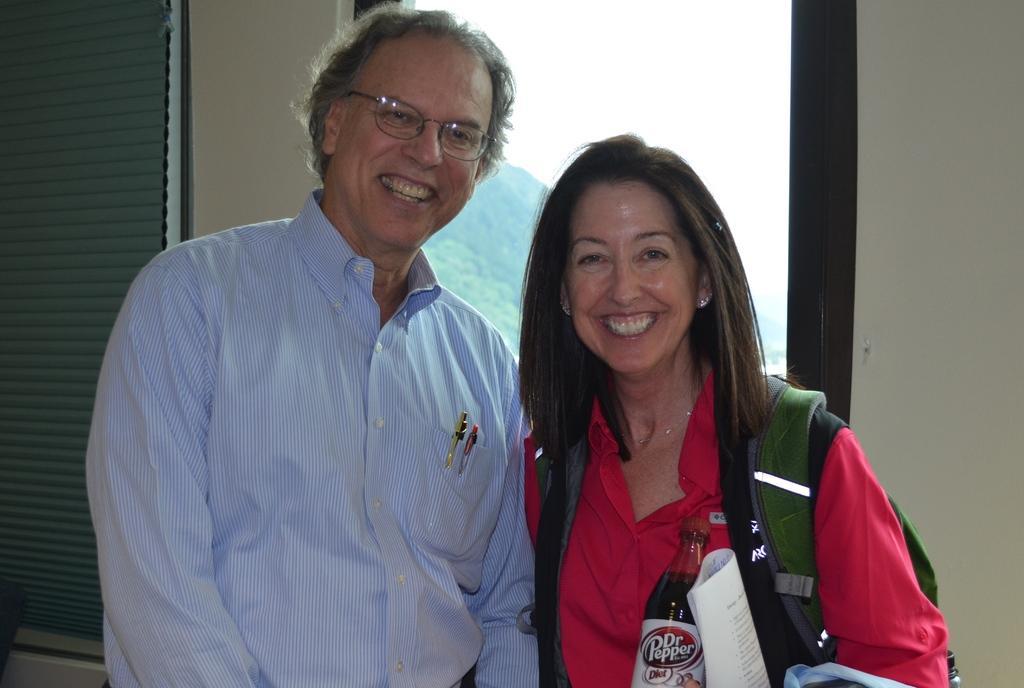Please provide a concise description of this image. In this image I can see two people are standing and smiling. Among them one person is wearing the blue shirt and another one is wearing the red shirt. Woman is holding a paper and bottle. And she is wearing the bag. To the left there is a window blind and In the back there are trees and the sky. 